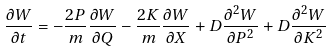<formula> <loc_0><loc_0><loc_500><loc_500>\frac { \partial W } { \partial t } = - \frac { 2 P } { m } \frac { \partial W } { \partial Q } - \frac { 2 K } { m } \frac { \partial W } { \partial X } + D \frac { \partial ^ { 2 } W } { \partial P ^ { 2 } } + D \frac { \partial ^ { 2 } W } { \partial K ^ { 2 } }</formula> 